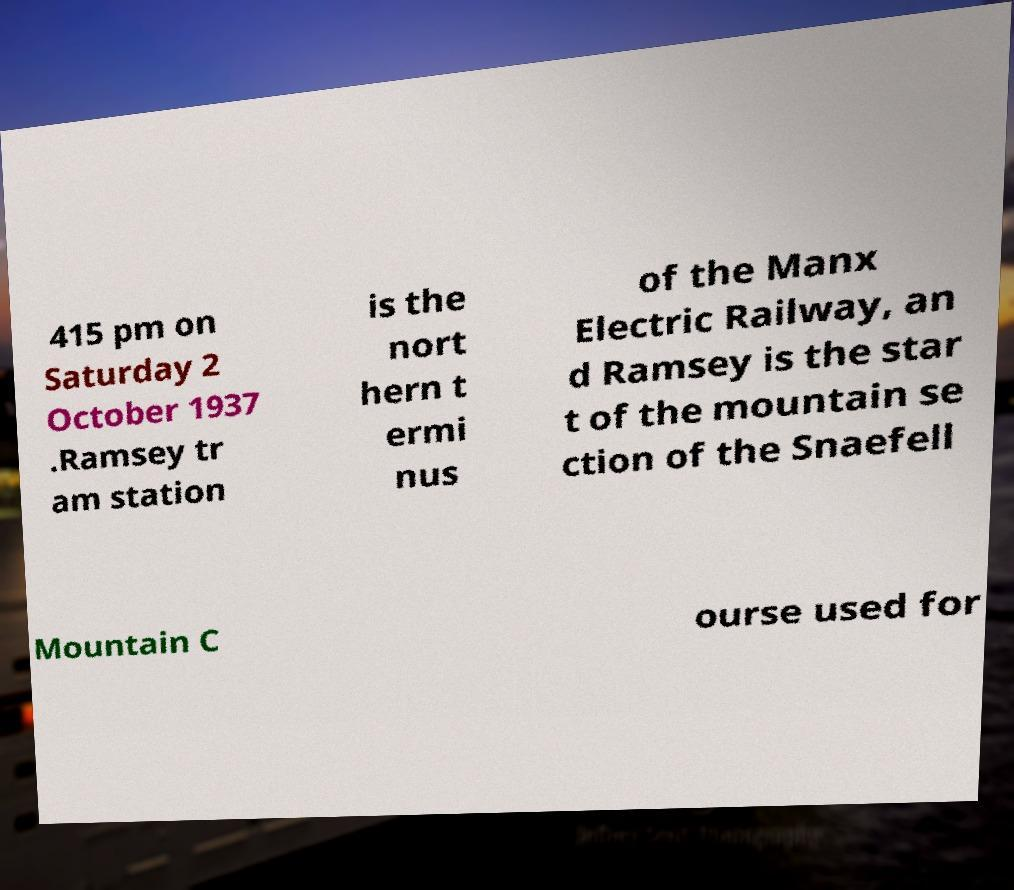Please read and relay the text visible in this image. What does it say? 415 pm on Saturday 2 October 1937 .Ramsey tr am station is the nort hern t ermi nus of the Manx Electric Railway, an d Ramsey is the star t of the mountain se ction of the Snaefell Mountain C ourse used for 